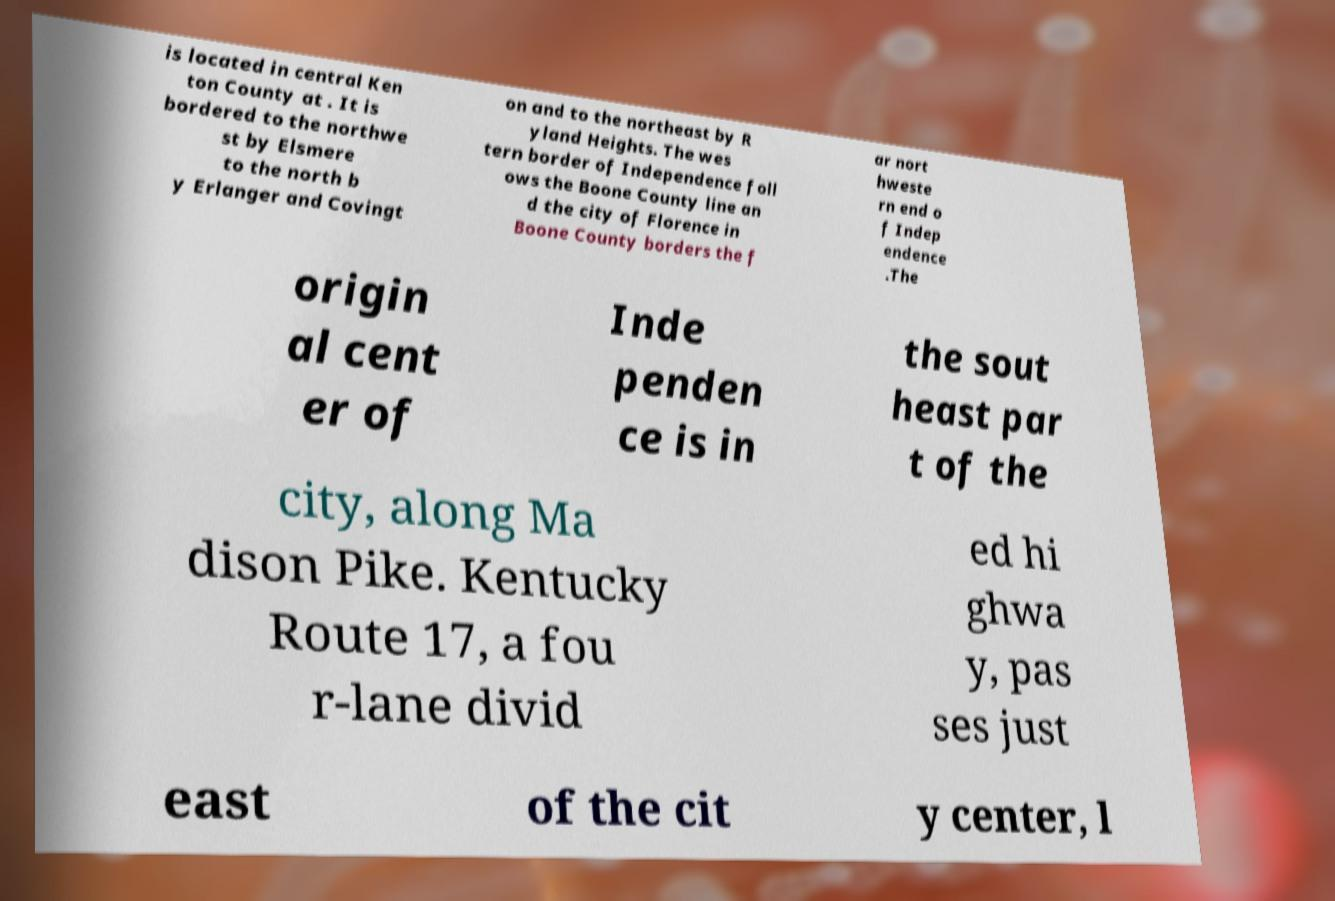For documentation purposes, I need the text within this image transcribed. Could you provide that? is located in central Ken ton County at . It is bordered to the northwe st by Elsmere to the north b y Erlanger and Covingt on and to the northeast by R yland Heights. The wes tern border of Independence foll ows the Boone County line an d the city of Florence in Boone County borders the f ar nort hweste rn end o f Indep endence .The origin al cent er of Inde penden ce is in the sout heast par t of the city, along Ma dison Pike. Kentucky Route 17, a fou r-lane divid ed hi ghwa y, pas ses just east of the cit y center, l 